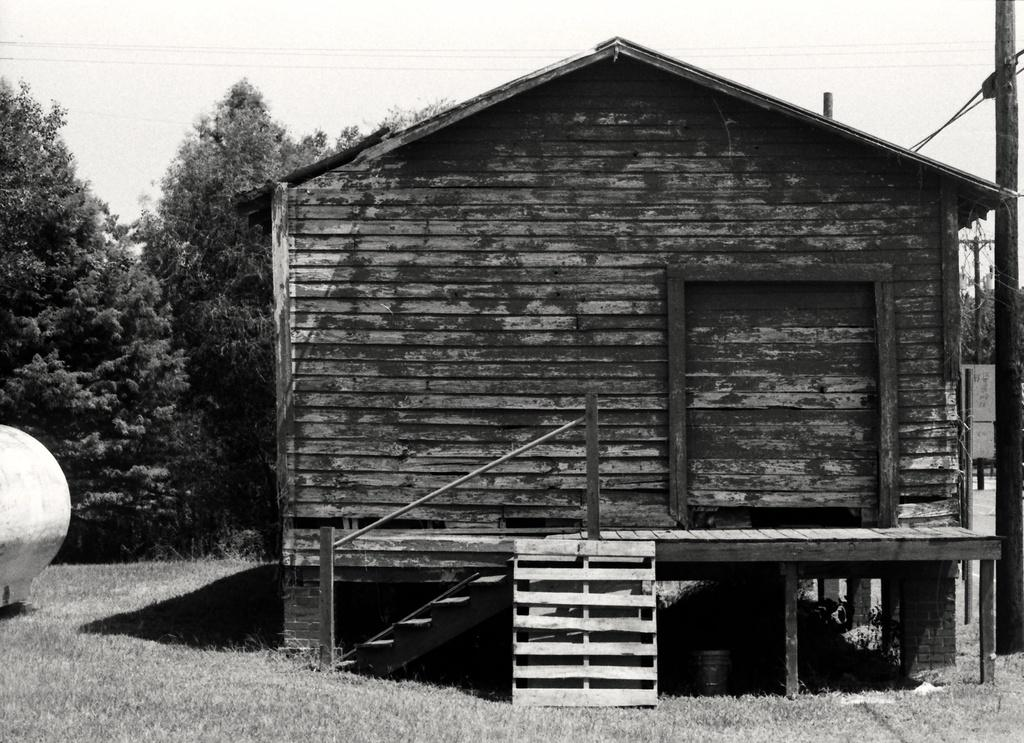What is the color scheme of the image? The image is black and white. What type of structure is present in the image? There is a building with woods in the image. What type of vegetation is on the ground in the image? There is grass on the ground in the image. What can be seen in the background of the image? There are trees and the sky visible in the background of the image. What type of rice is being cooked by the father in the image? There is no father or rice present in the image. Is the image hot or cold? The image itself is neither hot nor cold; it is a static representation. 